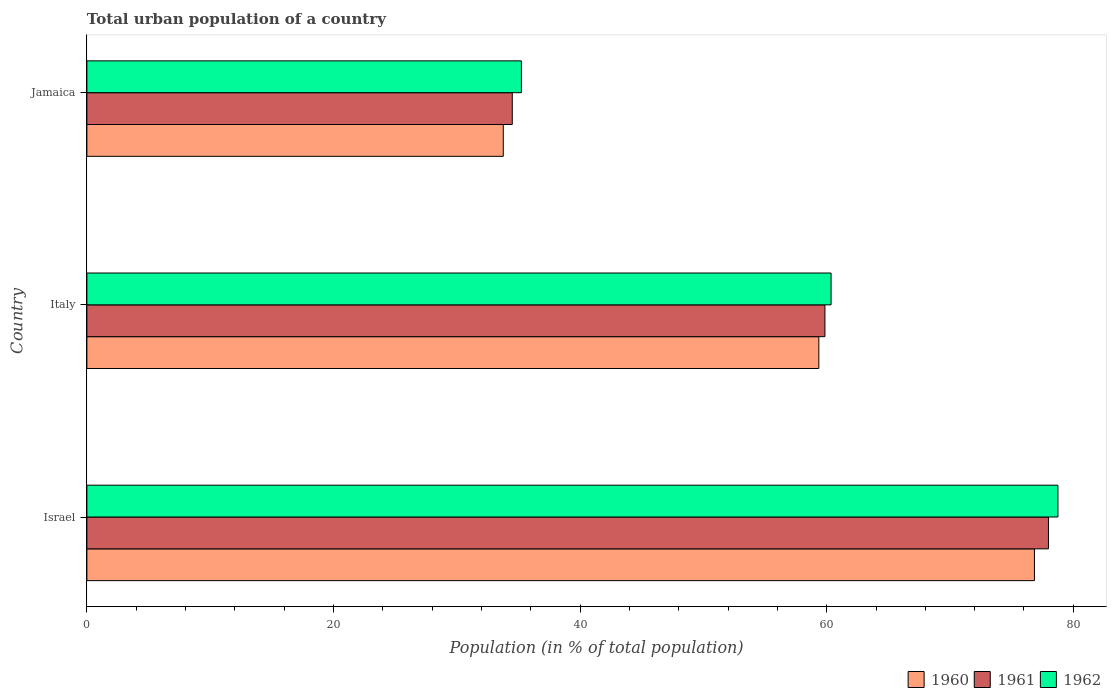How many different coloured bars are there?
Ensure brevity in your answer.  3. How many groups of bars are there?
Provide a succinct answer. 3. Are the number of bars per tick equal to the number of legend labels?
Provide a succinct answer. Yes. How many bars are there on the 1st tick from the bottom?
Make the answer very short. 3. What is the label of the 3rd group of bars from the top?
Give a very brief answer. Israel. In how many cases, is the number of bars for a given country not equal to the number of legend labels?
Your answer should be compact. 0. What is the urban population in 1960 in Israel?
Your response must be concise. 76.85. Across all countries, what is the maximum urban population in 1960?
Your answer should be very brief. 76.85. Across all countries, what is the minimum urban population in 1960?
Give a very brief answer. 33.77. In which country was the urban population in 1961 maximum?
Make the answer very short. Israel. In which country was the urban population in 1960 minimum?
Offer a terse response. Jamaica. What is the total urban population in 1962 in the graph?
Your answer should be compact. 174.35. What is the difference between the urban population in 1962 in Italy and that in Jamaica?
Make the answer very short. 25.12. What is the difference between the urban population in 1960 in Israel and the urban population in 1961 in Jamaica?
Provide a short and direct response. 42.35. What is the average urban population in 1962 per country?
Ensure brevity in your answer.  58.12. What is the difference between the urban population in 1962 and urban population in 1960 in Jamaica?
Provide a succinct answer. 1.47. What is the ratio of the urban population in 1960 in Israel to that in Italy?
Offer a terse response. 1.29. Is the urban population in 1961 in Israel less than that in Jamaica?
Keep it short and to the point. No. What is the difference between the highest and the second highest urban population in 1962?
Keep it short and to the point. 18.4. What is the difference between the highest and the lowest urban population in 1960?
Your response must be concise. 43.08. In how many countries, is the urban population in 1960 greater than the average urban population in 1960 taken over all countries?
Offer a very short reply. 2. Is the sum of the urban population in 1961 in Israel and Jamaica greater than the maximum urban population in 1960 across all countries?
Your answer should be compact. Yes. What does the 3rd bar from the top in Jamaica represents?
Provide a succinct answer. 1960. What does the 2nd bar from the bottom in Italy represents?
Keep it short and to the point. 1961. Are all the bars in the graph horizontal?
Your answer should be very brief. Yes. How many countries are there in the graph?
Give a very brief answer. 3. What is the difference between two consecutive major ticks on the X-axis?
Offer a very short reply. 20. Are the values on the major ticks of X-axis written in scientific E-notation?
Keep it short and to the point. No. Does the graph contain any zero values?
Ensure brevity in your answer.  No. Does the graph contain grids?
Provide a short and direct response. No. What is the title of the graph?
Ensure brevity in your answer.  Total urban population of a country. What is the label or title of the X-axis?
Offer a very short reply. Population (in % of total population). What is the Population (in % of total population) in 1960 in Israel?
Provide a short and direct response. 76.85. What is the Population (in % of total population) in 1961 in Israel?
Keep it short and to the point. 77.98. What is the Population (in % of total population) of 1962 in Israel?
Offer a very short reply. 78.75. What is the Population (in % of total population) of 1960 in Italy?
Your response must be concise. 59.36. What is the Population (in % of total population) of 1961 in Italy?
Offer a very short reply. 59.86. What is the Population (in % of total population) in 1962 in Italy?
Provide a short and direct response. 60.35. What is the Population (in % of total population) of 1960 in Jamaica?
Make the answer very short. 33.77. What is the Population (in % of total population) in 1961 in Jamaica?
Make the answer very short. 34.5. What is the Population (in % of total population) of 1962 in Jamaica?
Your response must be concise. 35.24. Across all countries, what is the maximum Population (in % of total population) in 1960?
Your answer should be very brief. 76.85. Across all countries, what is the maximum Population (in % of total population) of 1961?
Provide a succinct answer. 77.98. Across all countries, what is the maximum Population (in % of total population) of 1962?
Offer a very short reply. 78.75. Across all countries, what is the minimum Population (in % of total population) in 1960?
Keep it short and to the point. 33.77. Across all countries, what is the minimum Population (in % of total population) in 1961?
Keep it short and to the point. 34.5. Across all countries, what is the minimum Population (in % of total population) in 1962?
Keep it short and to the point. 35.24. What is the total Population (in % of total population) of 1960 in the graph?
Your answer should be very brief. 169.98. What is the total Population (in % of total population) in 1961 in the graph?
Make the answer very short. 172.34. What is the total Population (in % of total population) in 1962 in the graph?
Your response must be concise. 174.35. What is the difference between the Population (in % of total population) in 1960 in Israel and that in Italy?
Provide a short and direct response. 17.49. What is the difference between the Population (in % of total population) of 1961 in Israel and that in Italy?
Give a very brief answer. 18.13. What is the difference between the Population (in % of total population) in 1962 in Israel and that in Italy?
Offer a terse response. 18.4. What is the difference between the Population (in % of total population) of 1960 in Israel and that in Jamaica?
Your response must be concise. 43.08. What is the difference between the Population (in % of total population) of 1961 in Israel and that in Jamaica?
Offer a very short reply. 43.48. What is the difference between the Population (in % of total population) in 1962 in Israel and that in Jamaica?
Give a very brief answer. 43.52. What is the difference between the Population (in % of total population) in 1960 in Italy and that in Jamaica?
Provide a succinct answer. 25.59. What is the difference between the Population (in % of total population) of 1961 in Italy and that in Jamaica?
Offer a terse response. 25.36. What is the difference between the Population (in % of total population) in 1962 in Italy and that in Jamaica?
Offer a terse response. 25.12. What is the difference between the Population (in % of total population) in 1960 in Israel and the Population (in % of total population) in 1961 in Italy?
Make the answer very short. 16.99. What is the difference between the Population (in % of total population) in 1960 in Israel and the Population (in % of total population) in 1962 in Italy?
Provide a succinct answer. 16.49. What is the difference between the Population (in % of total population) of 1961 in Israel and the Population (in % of total population) of 1962 in Italy?
Make the answer very short. 17.63. What is the difference between the Population (in % of total population) of 1960 in Israel and the Population (in % of total population) of 1961 in Jamaica?
Keep it short and to the point. 42.35. What is the difference between the Population (in % of total population) of 1960 in Israel and the Population (in % of total population) of 1962 in Jamaica?
Provide a succinct answer. 41.61. What is the difference between the Population (in % of total population) of 1961 in Israel and the Population (in % of total population) of 1962 in Jamaica?
Provide a succinct answer. 42.75. What is the difference between the Population (in % of total population) of 1960 in Italy and the Population (in % of total population) of 1961 in Jamaica?
Ensure brevity in your answer.  24.86. What is the difference between the Population (in % of total population) of 1960 in Italy and the Population (in % of total population) of 1962 in Jamaica?
Your answer should be compact. 24.12. What is the difference between the Population (in % of total population) of 1961 in Italy and the Population (in % of total population) of 1962 in Jamaica?
Make the answer very short. 24.62. What is the average Population (in % of total population) in 1960 per country?
Offer a terse response. 56.66. What is the average Population (in % of total population) in 1961 per country?
Your answer should be compact. 57.45. What is the average Population (in % of total population) of 1962 per country?
Ensure brevity in your answer.  58.12. What is the difference between the Population (in % of total population) in 1960 and Population (in % of total population) in 1961 in Israel?
Offer a terse response. -1.14. What is the difference between the Population (in % of total population) in 1960 and Population (in % of total population) in 1962 in Israel?
Your answer should be very brief. -1.91. What is the difference between the Population (in % of total population) of 1961 and Population (in % of total population) of 1962 in Israel?
Provide a succinct answer. -0.77. What is the difference between the Population (in % of total population) in 1960 and Population (in % of total population) in 1961 in Italy?
Provide a succinct answer. -0.49. What is the difference between the Population (in % of total population) of 1960 and Population (in % of total population) of 1962 in Italy?
Keep it short and to the point. -0.99. What is the difference between the Population (in % of total population) in 1961 and Population (in % of total population) in 1962 in Italy?
Provide a short and direct response. -0.5. What is the difference between the Population (in % of total population) of 1960 and Population (in % of total population) of 1961 in Jamaica?
Your response must be concise. -0.73. What is the difference between the Population (in % of total population) of 1960 and Population (in % of total population) of 1962 in Jamaica?
Keep it short and to the point. -1.47. What is the difference between the Population (in % of total population) of 1961 and Population (in % of total population) of 1962 in Jamaica?
Your answer should be very brief. -0.74. What is the ratio of the Population (in % of total population) of 1960 in Israel to that in Italy?
Make the answer very short. 1.29. What is the ratio of the Population (in % of total population) in 1961 in Israel to that in Italy?
Your response must be concise. 1.3. What is the ratio of the Population (in % of total population) in 1962 in Israel to that in Italy?
Your response must be concise. 1.3. What is the ratio of the Population (in % of total population) of 1960 in Israel to that in Jamaica?
Give a very brief answer. 2.28. What is the ratio of the Population (in % of total population) of 1961 in Israel to that in Jamaica?
Offer a very short reply. 2.26. What is the ratio of the Population (in % of total population) in 1962 in Israel to that in Jamaica?
Ensure brevity in your answer.  2.23. What is the ratio of the Population (in % of total population) in 1960 in Italy to that in Jamaica?
Offer a terse response. 1.76. What is the ratio of the Population (in % of total population) of 1961 in Italy to that in Jamaica?
Your response must be concise. 1.74. What is the ratio of the Population (in % of total population) in 1962 in Italy to that in Jamaica?
Give a very brief answer. 1.71. What is the difference between the highest and the second highest Population (in % of total population) of 1960?
Provide a succinct answer. 17.49. What is the difference between the highest and the second highest Population (in % of total population) in 1961?
Your answer should be very brief. 18.13. What is the difference between the highest and the second highest Population (in % of total population) of 1962?
Provide a succinct answer. 18.4. What is the difference between the highest and the lowest Population (in % of total population) of 1960?
Give a very brief answer. 43.08. What is the difference between the highest and the lowest Population (in % of total population) of 1961?
Offer a very short reply. 43.48. What is the difference between the highest and the lowest Population (in % of total population) of 1962?
Keep it short and to the point. 43.52. 